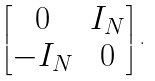<formula> <loc_0><loc_0><loc_500><loc_500>\begin{bmatrix} 0 & I _ { N } \\ - I _ { N } & 0 \end{bmatrix} .</formula> 